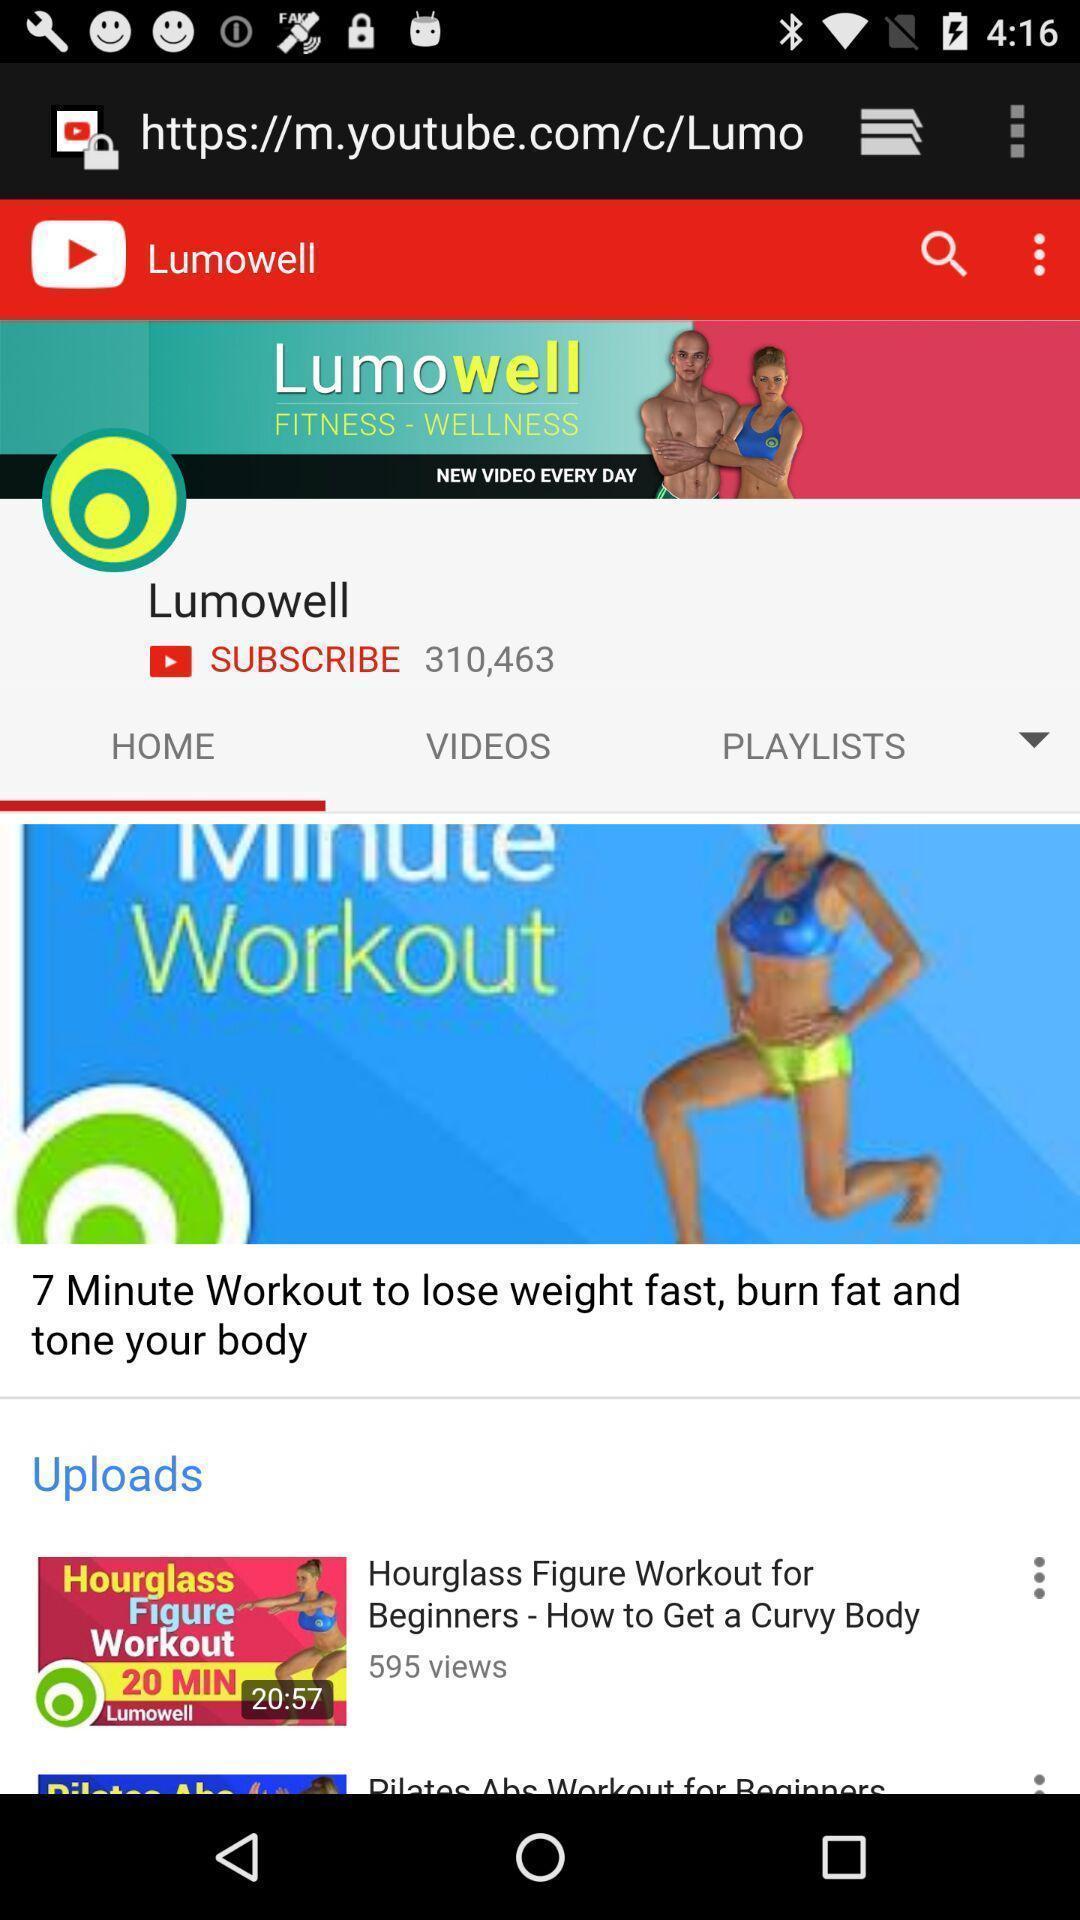Tell me what you see in this picture. Page shows the fitness application. 